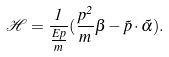Convert formula to latex. <formula><loc_0><loc_0><loc_500><loc_500>\mathcal { H } = \frac { 1 } { \frac { E p } { m } } ( \frac { p ^ { 2 } } { m } \beta - \vec { p } \cdot \vec { \alpha } ) .</formula> 